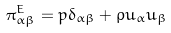Convert formula to latex. <formula><loc_0><loc_0><loc_500><loc_500>\pi ^ { E } _ { \alpha \beta } = p \delta _ { \alpha \beta } + \rho u _ { \alpha } u _ { \beta }</formula> 